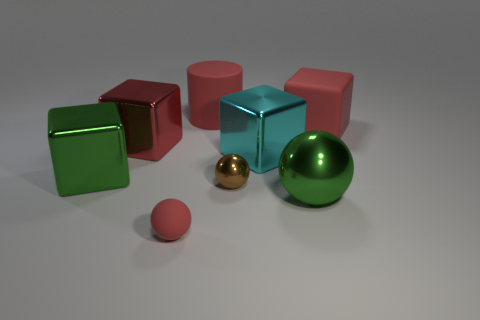There is a red cube on the right side of the tiny red rubber sphere that is in front of the big green shiny sphere; how big is it?
Provide a succinct answer. Large. Are there any metal balls of the same color as the rubber cylinder?
Offer a very short reply. No. There is a big matte object that is to the right of the big red cylinder; is its color the same as the large metal thing that is in front of the brown metal ball?
Give a very brief answer. No. What is the shape of the big cyan thing?
Provide a short and direct response. Cube. There is a cyan metallic block; how many large red cubes are in front of it?
Offer a very short reply. 0. How many tiny balls are the same material as the large red cylinder?
Offer a terse response. 1. Is the material of the small ball that is to the left of the matte cylinder the same as the big cyan cube?
Provide a short and direct response. No. Are any tiny red metal cylinders visible?
Your answer should be very brief. No. How big is the object that is in front of the cyan thing and to the right of the small brown ball?
Make the answer very short. Large. Is the number of matte cylinders right of the red rubber ball greater than the number of tiny balls behind the tiny metallic object?
Keep it short and to the point. Yes. 